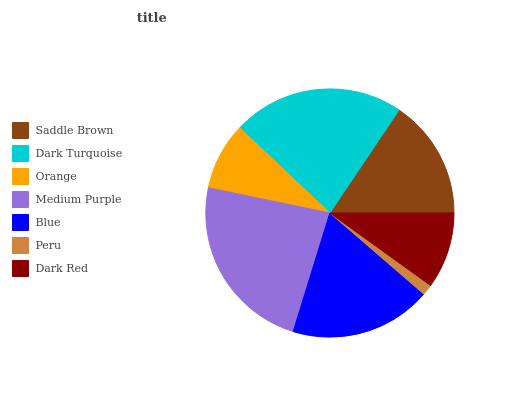Is Peru the minimum?
Answer yes or no. Yes. Is Medium Purple the maximum?
Answer yes or no. Yes. Is Dark Turquoise the minimum?
Answer yes or no. No. Is Dark Turquoise the maximum?
Answer yes or no. No. Is Dark Turquoise greater than Saddle Brown?
Answer yes or no. Yes. Is Saddle Brown less than Dark Turquoise?
Answer yes or no. Yes. Is Saddle Brown greater than Dark Turquoise?
Answer yes or no. No. Is Dark Turquoise less than Saddle Brown?
Answer yes or no. No. Is Saddle Brown the high median?
Answer yes or no. Yes. Is Saddle Brown the low median?
Answer yes or no. Yes. Is Peru the high median?
Answer yes or no. No. Is Dark Red the low median?
Answer yes or no. No. 